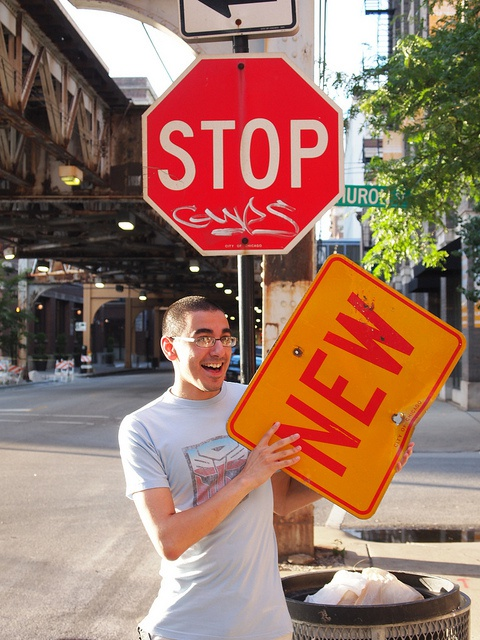Describe the objects in this image and their specific colors. I can see people in maroon, darkgray, white, and salmon tones and stop sign in maroon, red, tan, and salmon tones in this image. 